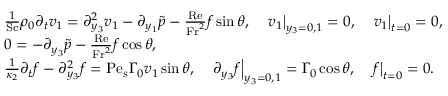<formula> <loc_0><loc_0><loc_500><loc_500>\begin{array} { r l } & { \frac { 1 } { S c } \rho _ { 0 } \partial _ { t } v _ { 1 } = \partial _ { y _ { 3 } } ^ { 2 } v _ { 1 } - \partial _ { y _ { 1 } } \tilde { p } - \frac { R e } { F r ^ { 2 } } f \sin \theta , \quad v _ { 1 } \right | _ { y _ { 3 } = 0 , 1 } = 0 , \quad v _ { 1 } \right | _ { t = 0 } = 0 , } \\ & { 0 = - \partial _ { y _ { 3 } } \tilde { p } - \frac { R e } { F r ^ { 2 } } f \cos \theta , } \\ & { \frac { 1 } { \kappa _ { 2 } } \partial _ { t } f - \partial _ { y _ { 3 } } ^ { 2 } f = P e _ { s } \Gamma _ { 0 } v _ { 1 } \sin \theta , \quad \partial _ { y _ { 3 } } f \right | _ { y _ { 3 } = 0 , 1 } = \Gamma _ { 0 } \cos \theta , \quad f \right | _ { t = 0 } = 0 . } \end{array}</formula> 